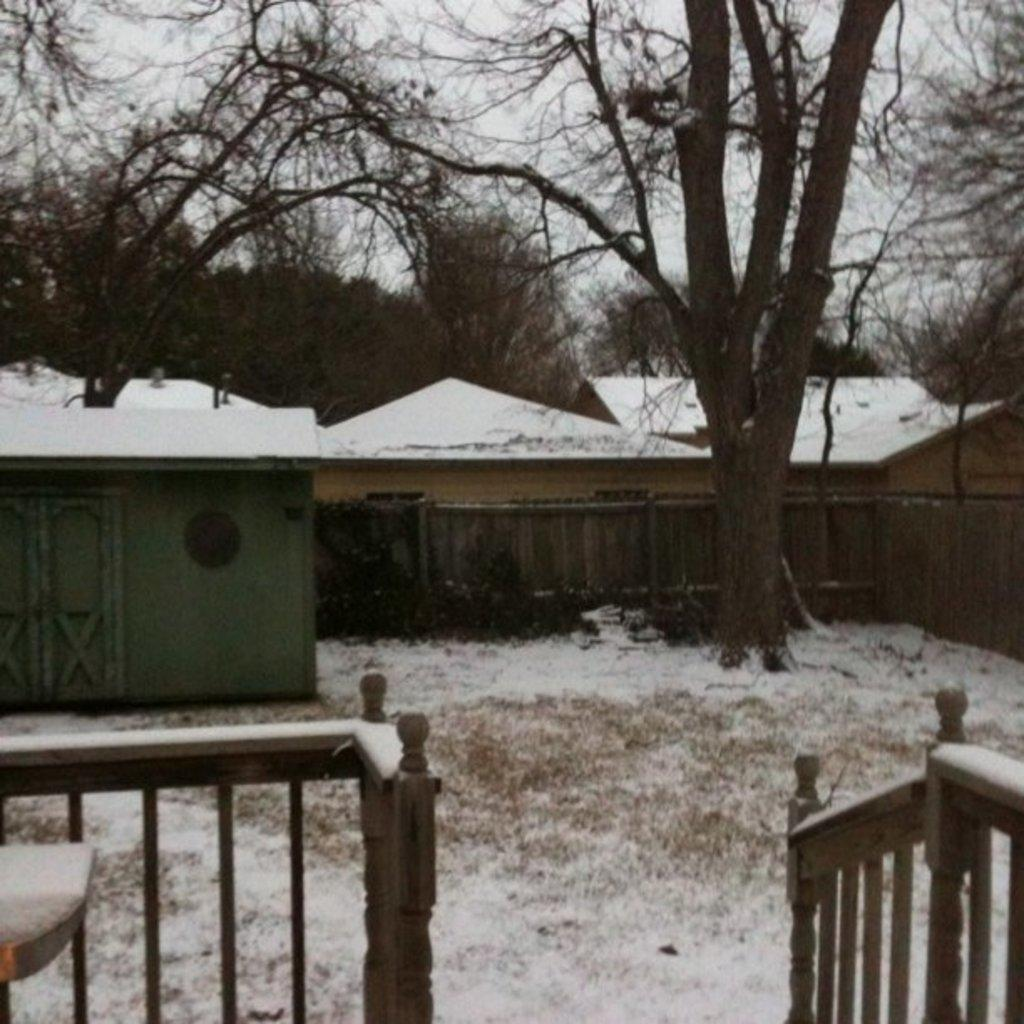What type of structures can be seen in the image? There are houses in the image. What other natural elements are present in the image? There are trees in the image. What type of barrier is visible in the image? There is fencing in the image. What is the weather condition in the image? There is snow visible in the image, indicating a cold or wintery condition. What color is the sky in the image? The sky is white in color. What type of glass is used to make the linen in the image? There is no glass or linen present in the image; it features houses, trees, fencing, snow, and a white sky. What time is indicated by the clock in the image? There is no clock present in the image. 